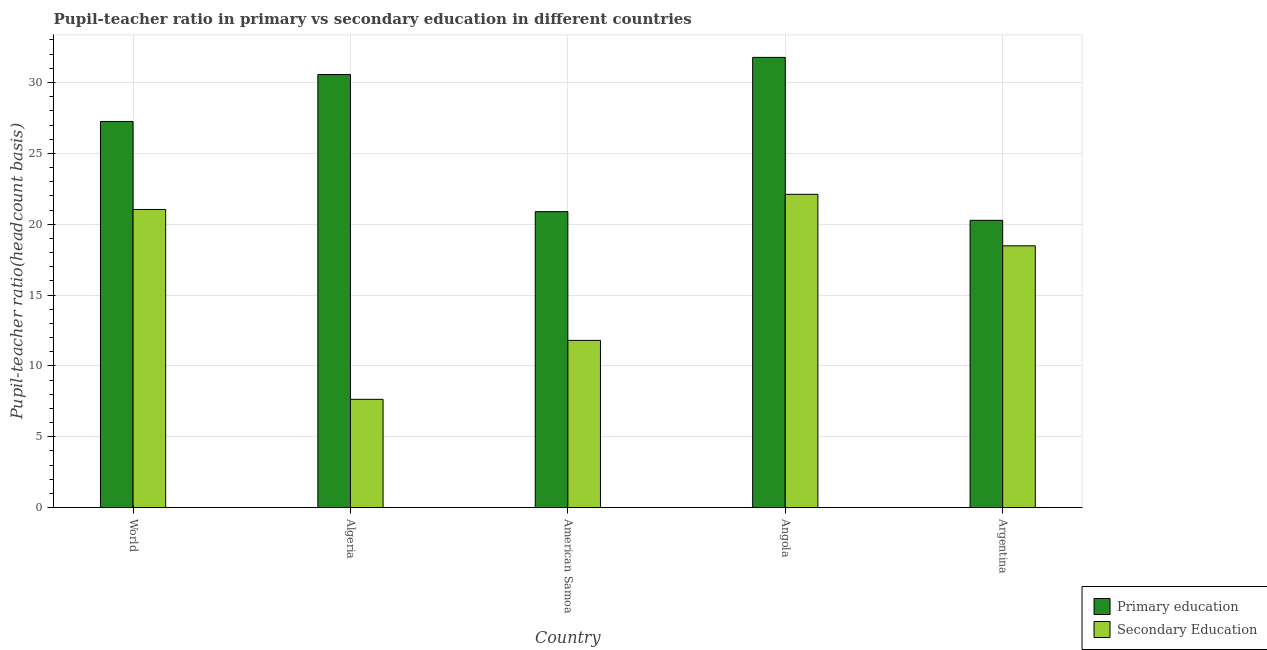Are the number of bars per tick equal to the number of legend labels?
Your answer should be very brief. Yes. How many bars are there on the 5th tick from the left?
Give a very brief answer. 2. How many bars are there on the 1st tick from the right?
Your answer should be very brief. 2. What is the label of the 4th group of bars from the left?
Offer a terse response. Angola. What is the pupil teacher ratio on secondary education in Angola?
Ensure brevity in your answer.  22.11. Across all countries, what is the maximum pupil teacher ratio on secondary education?
Provide a short and direct response. 22.11. Across all countries, what is the minimum pupil teacher ratio on secondary education?
Ensure brevity in your answer.  7.64. In which country was the pupil-teacher ratio in primary education maximum?
Your answer should be compact. Angola. What is the total pupil teacher ratio on secondary education in the graph?
Give a very brief answer. 81.07. What is the difference between the pupil teacher ratio on secondary education in Algeria and that in American Samoa?
Give a very brief answer. -4.16. What is the difference between the pupil teacher ratio on secondary education in American Samoa and the pupil-teacher ratio in primary education in World?
Provide a succinct answer. -15.45. What is the average pupil-teacher ratio in primary education per country?
Your answer should be very brief. 26.15. What is the difference between the pupil-teacher ratio in primary education and pupil teacher ratio on secondary education in World?
Ensure brevity in your answer.  6.21. In how many countries, is the pupil teacher ratio on secondary education greater than 16 ?
Your answer should be compact. 3. What is the ratio of the pupil-teacher ratio in primary education in Angola to that in World?
Your answer should be very brief. 1.17. Is the difference between the pupil-teacher ratio in primary education in Angola and World greater than the difference between the pupil teacher ratio on secondary education in Angola and World?
Make the answer very short. Yes. What is the difference between the highest and the second highest pupil-teacher ratio in primary education?
Ensure brevity in your answer.  1.21. What is the difference between the highest and the lowest pupil teacher ratio on secondary education?
Provide a short and direct response. 14.47. Is the sum of the pupil-teacher ratio in primary education in American Samoa and Argentina greater than the maximum pupil teacher ratio on secondary education across all countries?
Your answer should be very brief. Yes. What does the 2nd bar from the left in Angola represents?
Your answer should be very brief. Secondary Education. What does the 1st bar from the right in World represents?
Offer a very short reply. Secondary Education. Are all the bars in the graph horizontal?
Offer a terse response. No. How many countries are there in the graph?
Ensure brevity in your answer.  5. Are the values on the major ticks of Y-axis written in scientific E-notation?
Give a very brief answer. No. Does the graph contain any zero values?
Offer a very short reply. No. How are the legend labels stacked?
Offer a very short reply. Vertical. What is the title of the graph?
Give a very brief answer. Pupil-teacher ratio in primary vs secondary education in different countries. Does "Private credit bureau" appear as one of the legend labels in the graph?
Make the answer very short. No. What is the label or title of the Y-axis?
Provide a succinct answer. Pupil-teacher ratio(headcount basis). What is the Pupil-teacher ratio(headcount basis) in Primary education in World?
Your answer should be compact. 27.25. What is the Pupil-teacher ratio(headcount basis) of Secondary Education in World?
Offer a very short reply. 21.04. What is the Pupil-teacher ratio(headcount basis) in Primary education in Algeria?
Offer a terse response. 30.56. What is the Pupil-teacher ratio(headcount basis) of Secondary Education in Algeria?
Your response must be concise. 7.64. What is the Pupil-teacher ratio(headcount basis) of Primary education in American Samoa?
Provide a succinct answer. 20.89. What is the Pupil-teacher ratio(headcount basis) of Secondary Education in American Samoa?
Provide a succinct answer. 11.8. What is the Pupil-teacher ratio(headcount basis) of Primary education in Angola?
Your response must be concise. 31.77. What is the Pupil-teacher ratio(headcount basis) in Secondary Education in Angola?
Keep it short and to the point. 22.11. What is the Pupil-teacher ratio(headcount basis) in Primary education in Argentina?
Your answer should be compact. 20.28. What is the Pupil-teacher ratio(headcount basis) of Secondary Education in Argentina?
Your answer should be compact. 18.47. Across all countries, what is the maximum Pupil-teacher ratio(headcount basis) in Primary education?
Offer a terse response. 31.77. Across all countries, what is the maximum Pupil-teacher ratio(headcount basis) in Secondary Education?
Offer a very short reply. 22.11. Across all countries, what is the minimum Pupil-teacher ratio(headcount basis) in Primary education?
Your response must be concise. 20.28. Across all countries, what is the minimum Pupil-teacher ratio(headcount basis) in Secondary Education?
Your response must be concise. 7.64. What is the total Pupil-teacher ratio(headcount basis) in Primary education in the graph?
Offer a terse response. 130.75. What is the total Pupil-teacher ratio(headcount basis) of Secondary Education in the graph?
Ensure brevity in your answer.  81.07. What is the difference between the Pupil-teacher ratio(headcount basis) of Primary education in World and that in Algeria?
Offer a terse response. -3.31. What is the difference between the Pupil-teacher ratio(headcount basis) in Secondary Education in World and that in Algeria?
Offer a terse response. 13.4. What is the difference between the Pupil-teacher ratio(headcount basis) in Primary education in World and that in American Samoa?
Ensure brevity in your answer.  6.36. What is the difference between the Pupil-teacher ratio(headcount basis) of Secondary Education in World and that in American Samoa?
Give a very brief answer. 9.24. What is the difference between the Pupil-teacher ratio(headcount basis) in Primary education in World and that in Angola?
Give a very brief answer. -4.52. What is the difference between the Pupil-teacher ratio(headcount basis) in Secondary Education in World and that in Angola?
Give a very brief answer. -1.07. What is the difference between the Pupil-teacher ratio(headcount basis) of Primary education in World and that in Argentina?
Your answer should be very brief. 6.98. What is the difference between the Pupil-teacher ratio(headcount basis) of Secondary Education in World and that in Argentina?
Ensure brevity in your answer.  2.57. What is the difference between the Pupil-teacher ratio(headcount basis) in Primary education in Algeria and that in American Samoa?
Your response must be concise. 9.67. What is the difference between the Pupil-teacher ratio(headcount basis) of Secondary Education in Algeria and that in American Samoa?
Ensure brevity in your answer.  -4.16. What is the difference between the Pupil-teacher ratio(headcount basis) of Primary education in Algeria and that in Angola?
Keep it short and to the point. -1.21. What is the difference between the Pupil-teacher ratio(headcount basis) of Secondary Education in Algeria and that in Angola?
Your answer should be very brief. -14.47. What is the difference between the Pupil-teacher ratio(headcount basis) in Primary education in Algeria and that in Argentina?
Keep it short and to the point. 10.29. What is the difference between the Pupil-teacher ratio(headcount basis) in Secondary Education in Algeria and that in Argentina?
Provide a short and direct response. -10.83. What is the difference between the Pupil-teacher ratio(headcount basis) in Primary education in American Samoa and that in Angola?
Your answer should be compact. -10.88. What is the difference between the Pupil-teacher ratio(headcount basis) in Secondary Education in American Samoa and that in Angola?
Offer a terse response. -10.31. What is the difference between the Pupil-teacher ratio(headcount basis) of Primary education in American Samoa and that in Argentina?
Give a very brief answer. 0.61. What is the difference between the Pupil-teacher ratio(headcount basis) of Secondary Education in American Samoa and that in Argentina?
Offer a very short reply. -6.67. What is the difference between the Pupil-teacher ratio(headcount basis) of Primary education in Angola and that in Argentina?
Give a very brief answer. 11.5. What is the difference between the Pupil-teacher ratio(headcount basis) of Secondary Education in Angola and that in Argentina?
Your answer should be compact. 3.64. What is the difference between the Pupil-teacher ratio(headcount basis) of Primary education in World and the Pupil-teacher ratio(headcount basis) of Secondary Education in Algeria?
Give a very brief answer. 19.61. What is the difference between the Pupil-teacher ratio(headcount basis) in Primary education in World and the Pupil-teacher ratio(headcount basis) in Secondary Education in American Samoa?
Your answer should be compact. 15.45. What is the difference between the Pupil-teacher ratio(headcount basis) in Primary education in World and the Pupil-teacher ratio(headcount basis) in Secondary Education in Angola?
Offer a terse response. 5.14. What is the difference between the Pupil-teacher ratio(headcount basis) in Primary education in World and the Pupil-teacher ratio(headcount basis) in Secondary Education in Argentina?
Offer a very short reply. 8.78. What is the difference between the Pupil-teacher ratio(headcount basis) of Primary education in Algeria and the Pupil-teacher ratio(headcount basis) of Secondary Education in American Samoa?
Ensure brevity in your answer.  18.76. What is the difference between the Pupil-teacher ratio(headcount basis) in Primary education in Algeria and the Pupil-teacher ratio(headcount basis) in Secondary Education in Angola?
Provide a short and direct response. 8.45. What is the difference between the Pupil-teacher ratio(headcount basis) in Primary education in Algeria and the Pupil-teacher ratio(headcount basis) in Secondary Education in Argentina?
Your answer should be very brief. 12.09. What is the difference between the Pupil-teacher ratio(headcount basis) in Primary education in American Samoa and the Pupil-teacher ratio(headcount basis) in Secondary Education in Angola?
Provide a succinct answer. -1.22. What is the difference between the Pupil-teacher ratio(headcount basis) of Primary education in American Samoa and the Pupil-teacher ratio(headcount basis) of Secondary Education in Argentina?
Ensure brevity in your answer.  2.41. What is the difference between the Pupil-teacher ratio(headcount basis) of Primary education in Angola and the Pupil-teacher ratio(headcount basis) of Secondary Education in Argentina?
Your answer should be compact. 13.3. What is the average Pupil-teacher ratio(headcount basis) in Primary education per country?
Keep it short and to the point. 26.15. What is the average Pupil-teacher ratio(headcount basis) of Secondary Education per country?
Offer a terse response. 16.21. What is the difference between the Pupil-teacher ratio(headcount basis) in Primary education and Pupil-teacher ratio(headcount basis) in Secondary Education in World?
Provide a succinct answer. 6.21. What is the difference between the Pupil-teacher ratio(headcount basis) in Primary education and Pupil-teacher ratio(headcount basis) in Secondary Education in Algeria?
Provide a succinct answer. 22.92. What is the difference between the Pupil-teacher ratio(headcount basis) of Primary education and Pupil-teacher ratio(headcount basis) of Secondary Education in American Samoa?
Provide a succinct answer. 9.09. What is the difference between the Pupil-teacher ratio(headcount basis) of Primary education and Pupil-teacher ratio(headcount basis) of Secondary Education in Angola?
Your answer should be very brief. 9.66. What is the difference between the Pupil-teacher ratio(headcount basis) of Primary education and Pupil-teacher ratio(headcount basis) of Secondary Education in Argentina?
Keep it short and to the point. 1.8. What is the ratio of the Pupil-teacher ratio(headcount basis) of Primary education in World to that in Algeria?
Offer a very short reply. 0.89. What is the ratio of the Pupil-teacher ratio(headcount basis) of Secondary Education in World to that in Algeria?
Keep it short and to the point. 2.75. What is the ratio of the Pupil-teacher ratio(headcount basis) in Primary education in World to that in American Samoa?
Your answer should be very brief. 1.3. What is the ratio of the Pupil-teacher ratio(headcount basis) in Secondary Education in World to that in American Samoa?
Your answer should be very brief. 1.78. What is the ratio of the Pupil-teacher ratio(headcount basis) in Primary education in World to that in Angola?
Give a very brief answer. 0.86. What is the ratio of the Pupil-teacher ratio(headcount basis) of Secondary Education in World to that in Angola?
Provide a short and direct response. 0.95. What is the ratio of the Pupil-teacher ratio(headcount basis) in Primary education in World to that in Argentina?
Ensure brevity in your answer.  1.34. What is the ratio of the Pupil-teacher ratio(headcount basis) in Secondary Education in World to that in Argentina?
Your response must be concise. 1.14. What is the ratio of the Pupil-teacher ratio(headcount basis) of Primary education in Algeria to that in American Samoa?
Offer a terse response. 1.46. What is the ratio of the Pupil-teacher ratio(headcount basis) in Secondary Education in Algeria to that in American Samoa?
Give a very brief answer. 0.65. What is the ratio of the Pupil-teacher ratio(headcount basis) of Primary education in Algeria to that in Angola?
Your response must be concise. 0.96. What is the ratio of the Pupil-teacher ratio(headcount basis) in Secondary Education in Algeria to that in Angola?
Your response must be concise. 0.35. What is the ratio of the Pupil-teacher ratio(headcount basis) of Primary education in Algeria to that in Argentina?
Make the answer very short. 1.51. What is the ratio of the Pupil-teacher ratio(headcount basis) of Secondary Education in Algeria to that in Argentina?
Provide a succinct answer. 0.41. What is the ratio of the Pupil-teacher ratio(headcount basis) in Primary education in American Samoa to that in Angola?
Make the answer very short. 0.66. What is the ratio of the Pupil-teacher ratio(headcount basis) in Secondary Education in American Samoa to that in Angola?
Give a very brief answer. 0.53. What is the ratio of the Pupil-teacher ratio(headcount basis) of Primary education in American Samoa to that in Argentina?
Give a very brief answer. 1.03. What is the ratio of the Pupil-teacher ratio(headcount basis) of Secondary Education in American Samoa to that in Argentina?
Ensure brevity in your answer.  0.64. What is the ratio of the Pupil-teacher ratio(headcount basis) of Primary education in Angola to that in Argentina?
Provide a succinct answer. 1.57. What is the ratio of the Pupil-teacher ratio(headcount basis) in Secondary Education in Angola to that in Argentina?
Your answer should be very brief. 1.2. What is the difference between the highest and the second highest Pupil-teacher ratio(headcount basis) of Primary education?
Ensure brevity in your answer.  1.21. What is the difference between the highest and the second highest Pupil-teacher ratio(headcount basis) in Secondary Education?
Your answer should be compact. 1.07. What is the difference between the highest and the lowest Pupil-teacher ratio(headcount basis) of Primary education?
Your answer should be very brief. 11.5. What is the difference between the highest and the lowest Pupil-teacher ratio(headcount basis) in Secondary Education?
Provide a short and direct response. 14.47. 